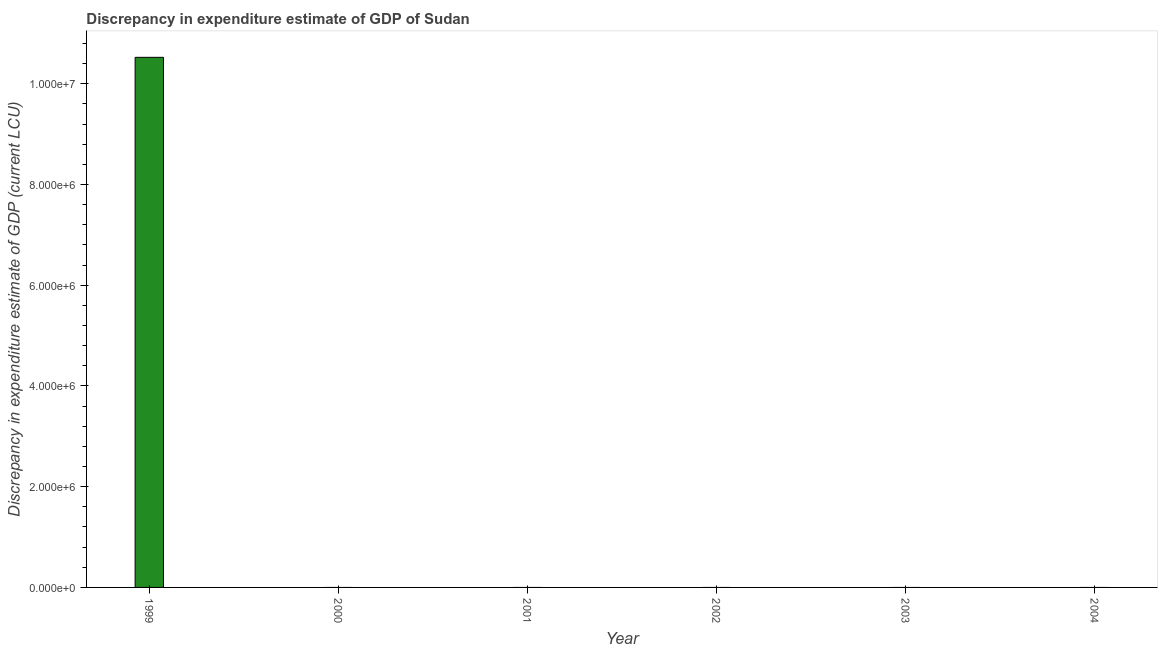What is the title of the graph?
Provide a short and direct response. Discrepancy in expenditure estimate of GDP of Sudan. What is the label or title of the Y-axis?
Your response must be concise. Discrepancy in expenditure estimate of GDP (current LCU). What is the discrepancy in expenditure estimate of gdp in 1999?
Ensure brevity in your answer.  1.05e+07. Across all years, what is the maximum discrepancy in expenditure estimate of gdp?
Keep it short and to the point. 1.05e+07. Across all years, what is the minimum discrepancy in expenditure estimate of gdp?
Make the answer very short. 0. In which year was the discrepancy in expenditure estimate of gdp maximum?
Make the answer very short. 1999. What is the sum of the discrepancy in expenditure estimate of gdp?
Your response must be concise. 1.05e+07. What is the average discrepancy in expenditure estimate of gdp per year?
Your answer should be compact. 1.75e+06. In how many years, is the discrepancy in expenditure estimate of gdp greater than 4800000 LCU?
Your response must be concise. 1. What is the difference between the highest and the lowest discrepancy in expenditure estimate of gdp?
Your response must be concise. 1.05e+07. In how many years, is the discrepancy in expenditure estimate of gdp greater than the average discrepancy in expenditure estimate of gdp taken over all years?
Your response must be concise. 1. How many years are there in the graph?
Your answer should be very brief. 6. Are the values on the major ticks of Y-axis written in scientific E-notation?
Ensure brevity in your answer.  Yes. What is the Discrepancy in expenditure estimate of GDP (current LCU) in 1999?
Provide a short and direct response. 1.05e+07. What is the Discrepancy in expenditure estimate of GDP (current LCU) in 2000?
Provide a succinct answer. 0. What is the Discrepancy in expenditure estimate of GDP (current LCU) in 2002?
Make the answer very short. 0. What is the Discrepancy in expenditure estimate of GDP (current LCU) of 2004?
Your answer should be very brief. 0. 